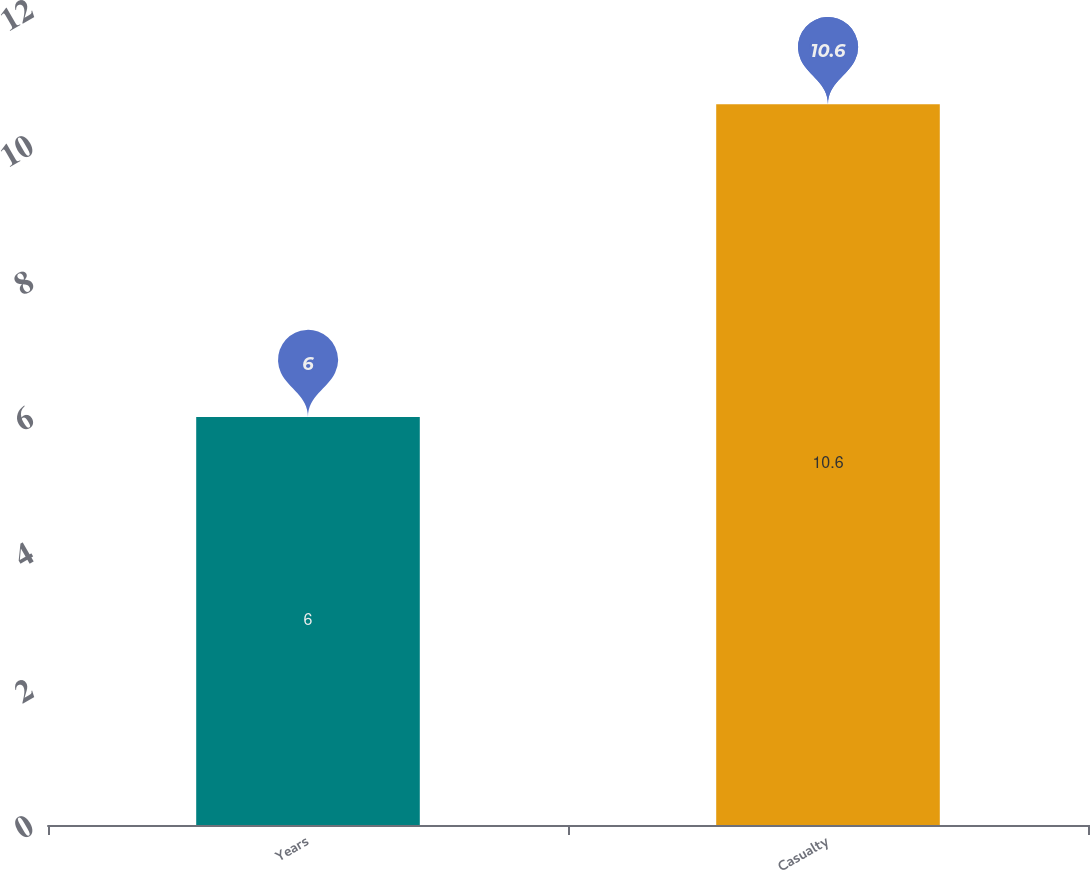Convert chart to OTSL. <chart><loc_0><loc_0><loc_500><loc_500><bar_chart><fcel>Years<fcel>Casualty<nl><fcel>6<fcel>10.6<nl></chart> 